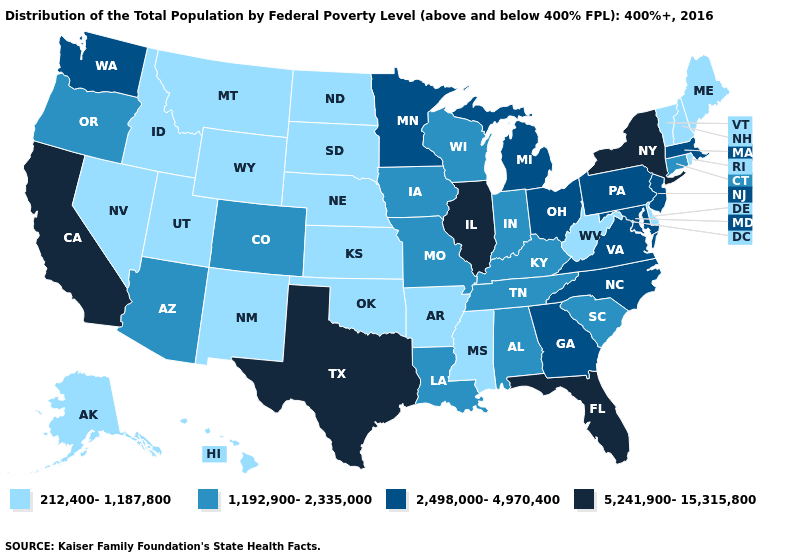What is the value of South Dakota?
Short answer required. 212,400-1,187,800. Name the states that have a value in the range 5,241,900-15,315,800?
Answer briefly. California, Florida, Illinois, New York, Texas. Does the first symbol in the legend represent the smallest category?
Quick response, please. Yes. Name the states that have a value in the range 5,241,900-15,315,800?
Write a very short answer. California, Florida, Illinois, New York, Texas. Which states have the lowest value in the USA?
Quick response, please. Alaska, Arkansas, Delaware, Hawaii, Idaho, Kansas, Maine, Mississippi, Montana, Nebraska, Nevada, New Hampshire, New Mexico, North Dakota, Oklahoma, Rhode Island, South Dakota, Utah, Vermont, West Virginia, Wyoming. Name the states that have a value in the range 212,400-1,187,800?
Answer briefly. Alaska, Arkansas, Delaware, Hawaii, Idaho, Kansas, Maine, Mississippi, Montana, Nebraska, Nevada, New Hampshire, New Mexico, North Dakota, Oklahoma, Rhode Island, South Dakota, Utah, Vermont, West Virginia, Wyoming. Among the states that border New Mexico , which have the lowest value?
Write a very short answer. Oklahoma, Utah. What is the value of Alabama?
Write a very short answer. 1,192,900-2,335,000. Name the states that have a value in the range 5,241,900-15,315,800?
Give a very brief answer. California, Florida, Illinois, New York, Texas. What is the lowest value in states that border Massachusetts?
Quick response, please. 212,400-1,187,800. What is the value of Minnesota?
Keep it brief. 2,498,000-4,970,400. Does Oregon have the lowest value in the West?
Be succinct. No. Does New York have a lower value than Utah?
Keep it brief. No. Does Massachusetts have the lowest value in the USA?
Quick response, please. No. Does Delaware have the lowest value in the South?
Short answer required. Yes. 